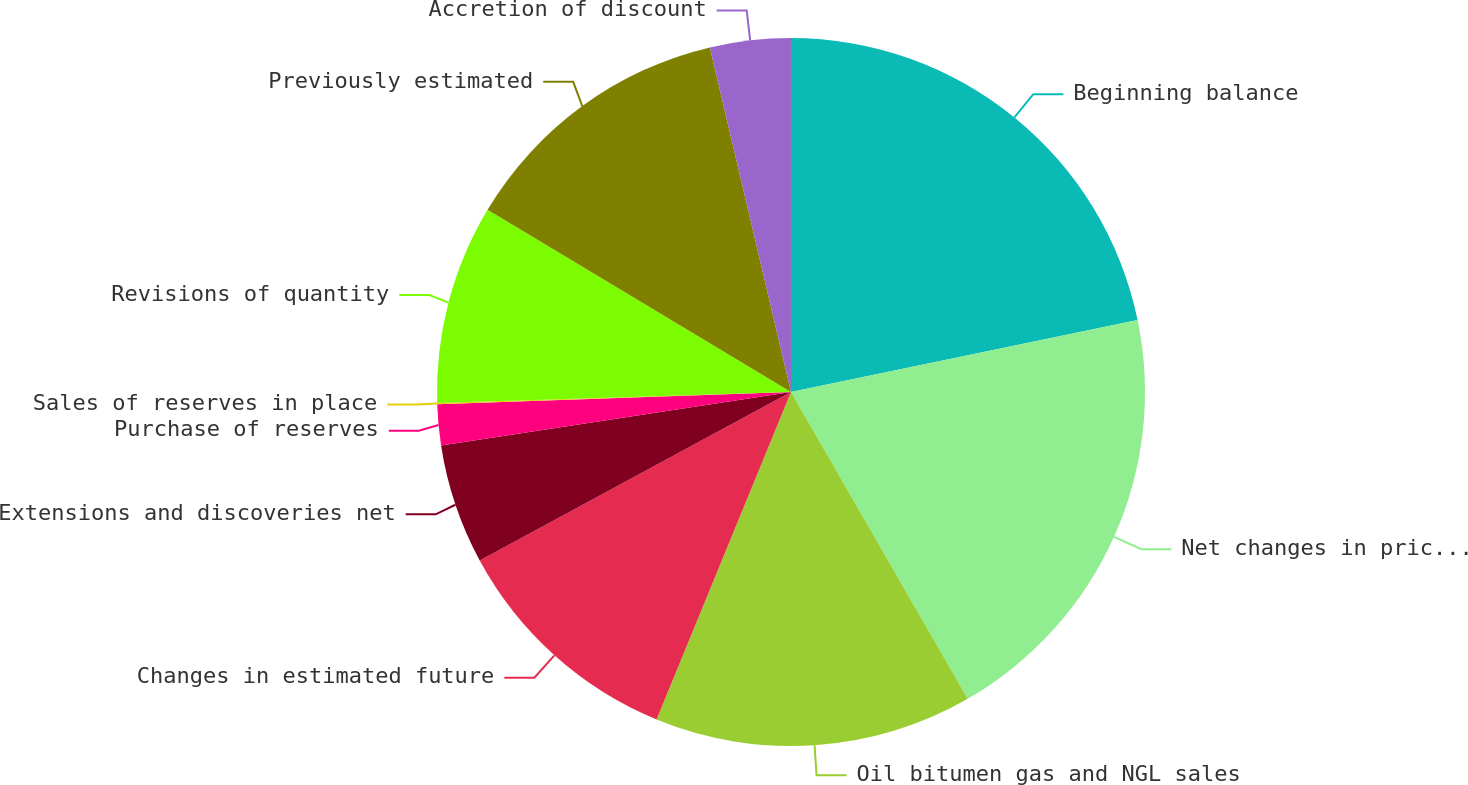<chart> <loc_0><loc_0><loc_500><loc_500><pie_chart><fcel>Beginning balance<fcel>Net changes in prices and<fcel>Oil bitumen gas and NGL sales<fcel>Changes in estimated future<fcel>Extensions and discoveries net<fcel>Purchase of reserves<fcel>Sales of reserves in place<fcel>Revisions of quantity<fcel>Previously estimated<fcel>Accretion of discount<nl><fcel>21.74%<fcel>19.94%<fcel>14.52%<fcel>10.9%<fcel>5.48%<fcel>1.87%<fcel>0.06%<fcel>9.1%<fcel>12.71%<fcel>3.68%<nl></chart> 